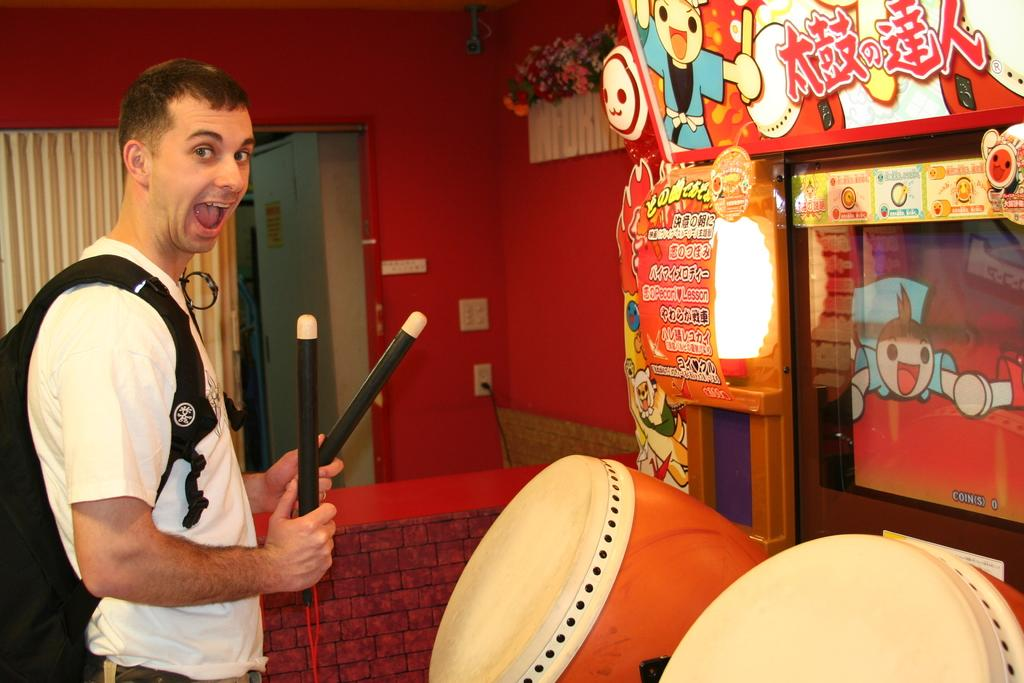Who is present in the image? There is a person in the image. Where is the person located? The person is in a room. What is the person doing in the room? The person is playing drums. What book is the person reading in the image? There is no book present in the image, and the person is playing drums, not reading. 